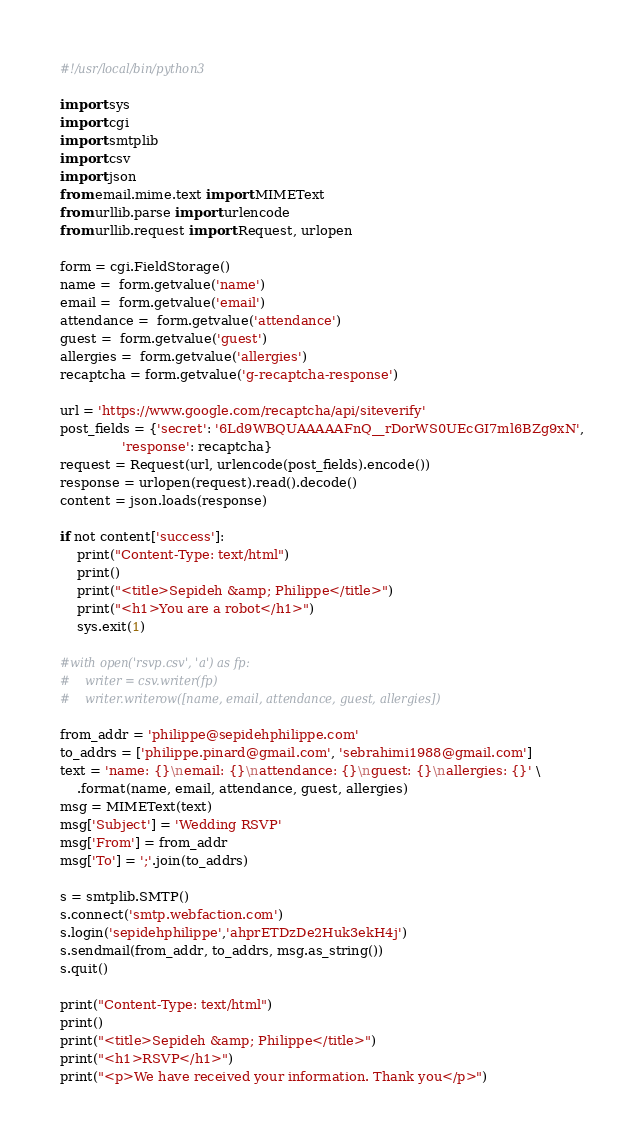<code> <loc_0><loc_0><loc_500><loc_500><_Python_>#!/usr/local/bin/python3

import sys
import cgi
import smtplib
import csv
import json
from email.mime.text import MIMEText
from urllib.parse import urlencode
from urllib.request import Request, urlopen

form = cgi.FieldStorage()
name =  form.getvalue('name')
email =  form.getvalue('email')
attendance =  form.getvalue('attendance')
guest =  form.getvalue('guest')
allergies =  form.getvalue('allergies')
recaptcha = form.getvalue('g-recaptcha-response')

url = 'https://www.google.com/recaptcha/api/siteverify'
post_fields = {'secret': '6Ld9WBQUAAAAAFnQ__rDorWS0UEcGI7ml6BZg9xN',
               'response': recaptcha}
request = Request(url, urlencode(post_fields).encode())
response = urlopen(request).read().decode()
content = json.loads(response)

if not content['success']:
    print("Content-Type: text/html")
    print()
    print("<title>Sepideh &amp; Philippe</title>")
    print("<h1>You are a robot</h1>")
    sys.exit(1)

#with open('rsvp.csv', 'a') as fp:
#    writer = csv.writer(fp)
#    writer.writerow([name, email, attendance, guest, allergies])

from_addr = 'philippe@sepidehphilippe.com'
to_addrs = ['philippe.pinard@gmail.com', 'sebrahimi1988@gmail.com']
text = 'name: {}\nemail: {}\nattendance: {}\nguest: {}\nallergies: {}' \
    .format(name, email, attendance, guest, allergies)
msg = MIMEText(text)
msg['Subject'] = 'Wedding RSVP'
msg['From'] = from_addr
msg['To'] = ';'.join(to_addrs)

s = smtplib.SMTP()
s.connect('smtp.webfaction.com')
s.login('sepidehphilippe','ahprETDzDe2Huk3ekH4j')
s.sendmail(from_addr, to_addrs, msg.as_string())
s.quit()

print("Content-Type: text/html")
print()
print("<title>Sepideh &amp; Philippe</title>")
print("<h1>RSVP</h1>")
print("<p>We have received your information. Thank you</p>")

</code> 